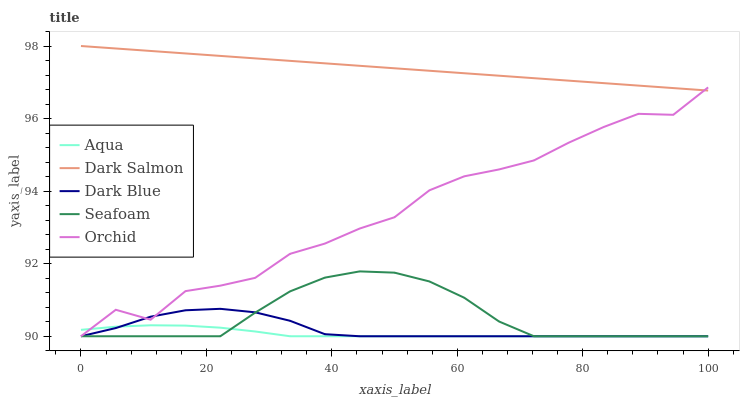Does Orchid have the minimum area under the curve?
Answer yes or no. No. Does Orchid have the maximum area under the curve?
Answer yes or no. No. Is Aqua the smoothest?
Answer yes or no. No. Is Aqua the roughest?
Answer yes or no. No. Does Dark Salmon have the lowest value?
Answer yes or no. No. Does Orchid have the highest value?
Answer yes or no. No. Is Dark Blue less than Dark Salmon?
Answer yes or no. Yes. Is Dark Salmon greater than Aqua?
Answer yes or no. Yes. Does Dark Blue intersect Dark Salmon?
Answer yes or no. No. 